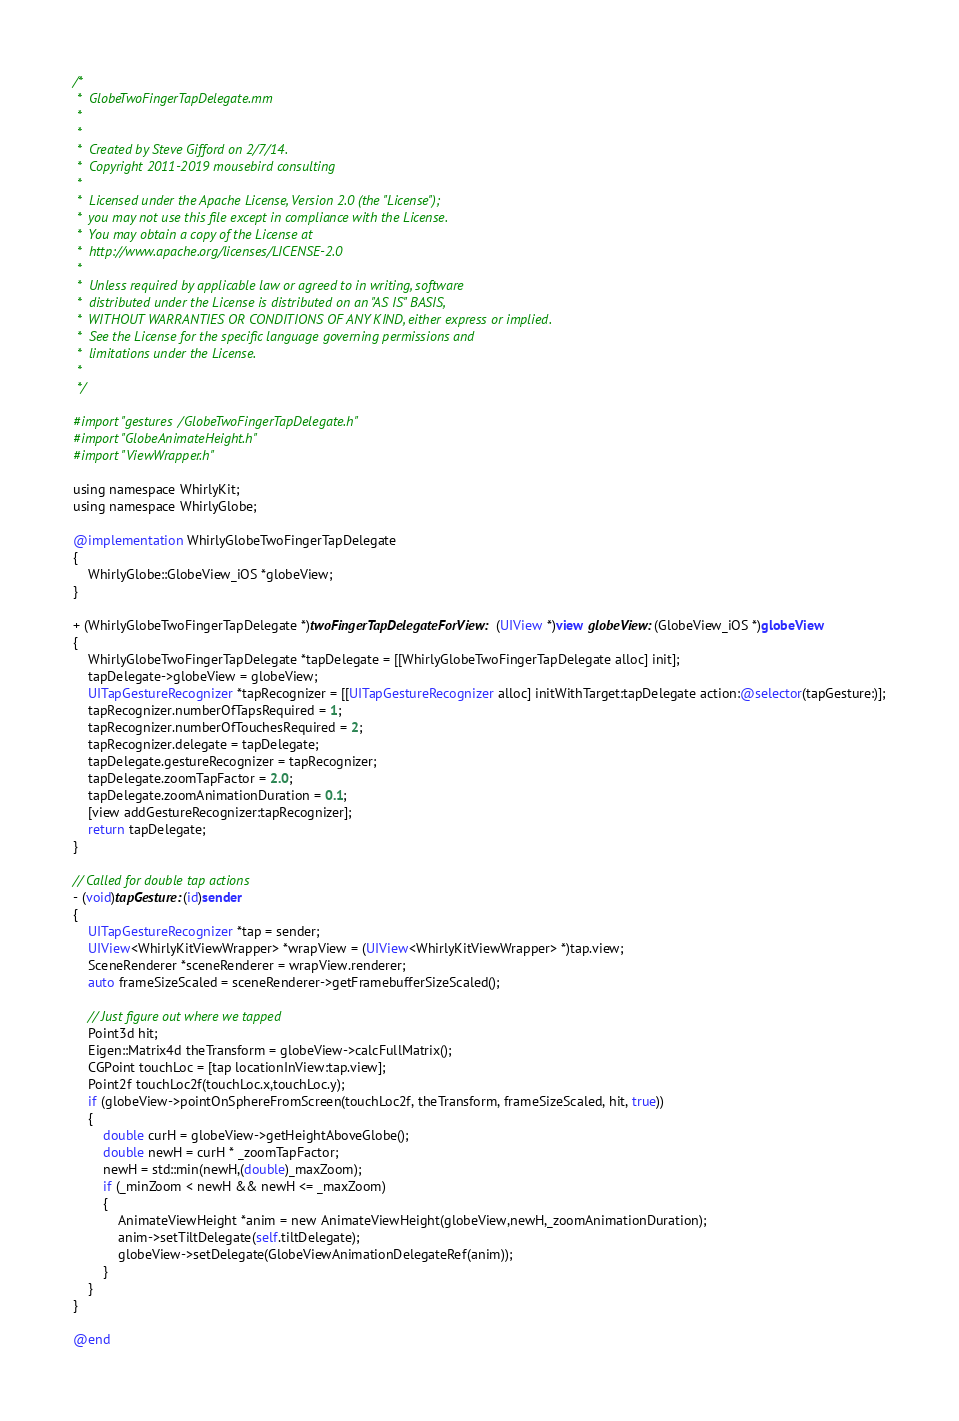Convert code to text. <code><loc_0><loc_0><loc_500><loc_500><_ObjectiveC_>/*
 *  GlobeTwoFingerTapDelegate.mm
 *
 *
 *  Created by Steve Gifford on 2/7/14.
 *  Copyright 2011-2019 mousebird consulting
 *
 *  Licensed under the Apache License, Version 2.0 (the "License");
 *  you may not use this file except in compliance with the License.
 *  You may obtain a copy of the License at
 *  http://www.apache.org/licenses/LICENSE-2.0
 *
 *  Unless required by applicable law or agreed to in writing, software
 *  distributed under the License is distributed on an "AS IS" BASIS,
 *  WITHOUT WARRANTIES OR CONDITIONS OF ANY KIND, either express or implied.
 *  See the License for the specific language governing permissions and
 *  limitations under the License.
 *
 */

#import "gestures/GlobeTwoFingerTapDelegate.h"
#import "GlobeAnimateHeight.h"
#import "ViewWrapper.h"

using namespace WhirlyKit;
using namespace WhirlyGlobe;

@implementation WhirlyGlobeTwoFingerTapDelegate
{
    WhirlyGlobe::GlobeView_iOS *globeView;
}

+ (WhirlyGlobeTwoFingerTapDelegate *)twoFingerTapDelegateForView:(UIView *)view globeView:(GlobeView_iOS *)globeView
{
    WhirlyGlobeTwoFingerTapDelegate *tapDelegate = [[WhirlyGlobeTwoFingerTapDelegate alloc] init];
    tapDelegate->globeView = globeView;
    UITapGestureRecognizer *tapRecognizer = [[UITapGestureRecognizer alloc] initWithTarget:tapDelegate action:@selector(tapGesture:)];
    tapRecognizer.numberOfTapsRequired = 1;
    tapRecognizer.numberOfTouchesRequired = 2;
    tapRecognizer.delegate = tapDelegate;
    tapDelegate.gestureRecognizer = tapRecognizer;
    tapDelegate.zoomTapFactor = 2.0;
    tapDelegate.zoomAnimationDuration = 0.1;
	[view addGestureRecognizer:tapRecognizer];
	return tapDelegate;
}

// Called for double tap actions
- (void)tapGesture:(id)sender
{
	UITapGestureRecognizer *tap = sender;
    UIView<WhirlyKitViewWrapper> *wrapView = (UIView<WhirlyKitViewWrapper> *)tap.view;
    SceneRenderer *sceneRenderer = wrapView.renderer;
    auto frameSizeScaled = sceneRenderer->getFramebufferSizeScaled();
	
    // Just figure out where we tapped
	Point3d hit;
    Eigen::Matrix4d theTransform = globeView->calcFullMatrix();
    CGPoint touchLoc = [tap locationInView:tap.view];
    Point2f touchLoc2f(touchLoc.x,touchLoc.y);
    if (globeView->pointOnSphereFromScreen(touchLoc2f, theTransform, frameSizeScaled, hit, true))
    {
        double curH = globeView->getHeightAboveGlobe();
        double newH = curH * _zoomTapFactor;
        newH = std::min(newH,(double)_maxZoom);
        if (_minZoom < newH && newH <= _maxZoom)
        {
            AnimateViewHeight *anim = new AnimateViewHeight(globeView,newH,_zoomAnimationDuration);
            anim->setTiltDelegate(self.tiltDelegate);
            globeView->setDelegate(GlobeViewAnimationDelegateRef(anim));
        }
    }
}

@end
</code> 